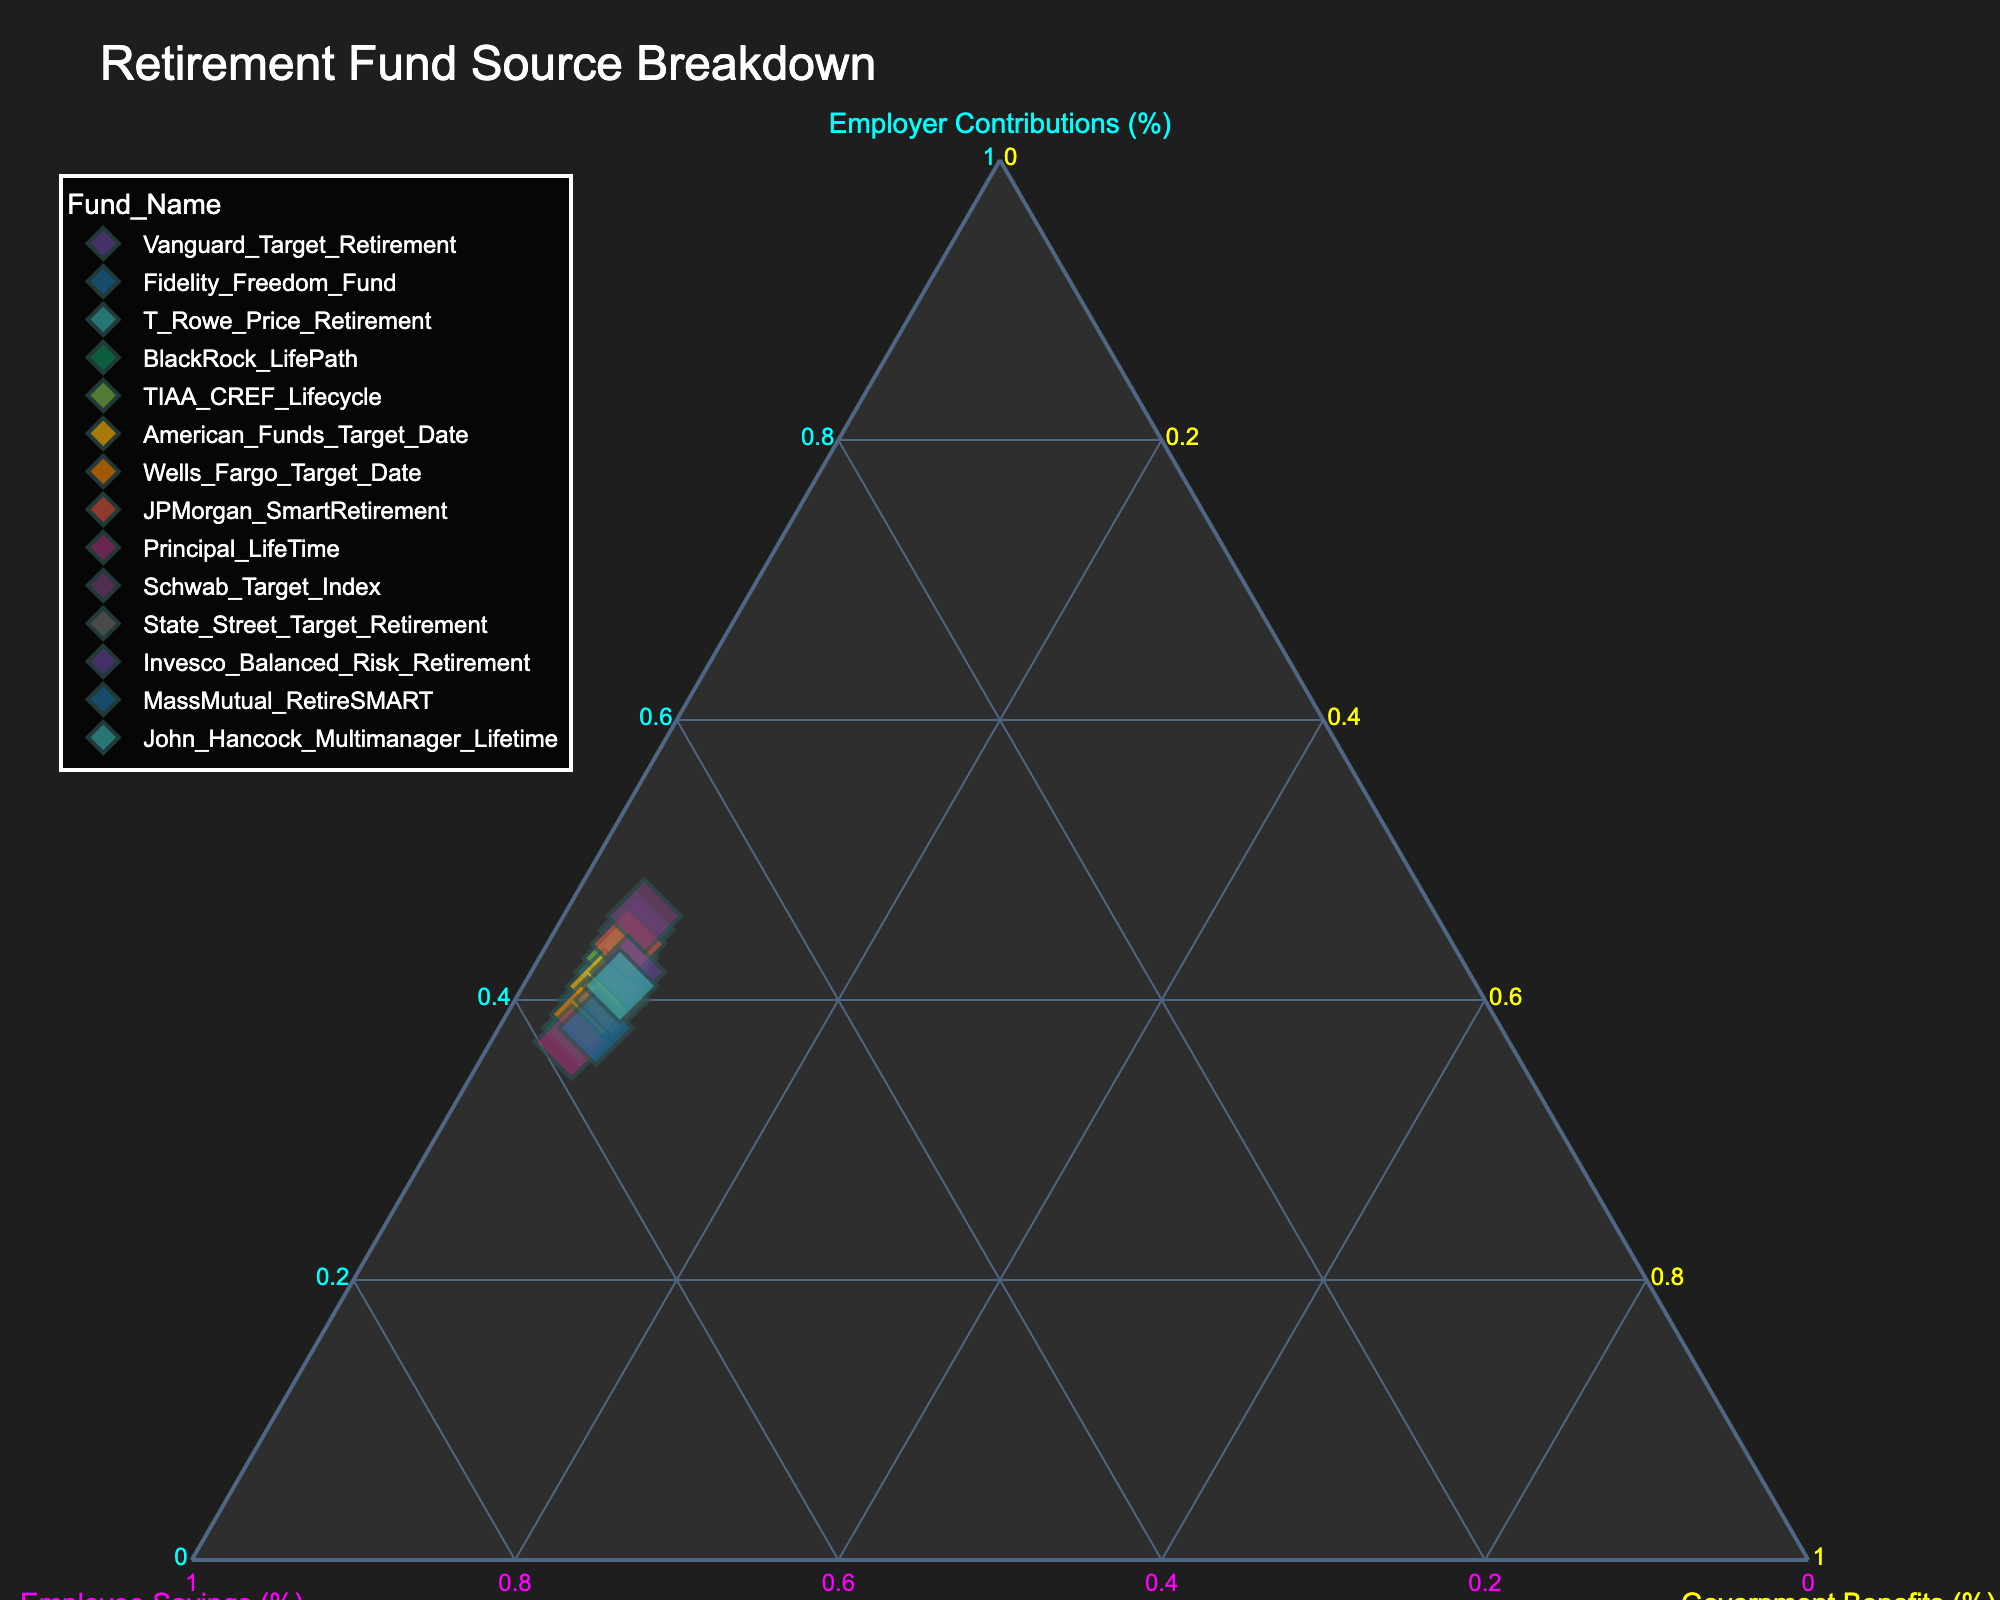How many data points are there on the plot? The plot has one marker per fund, and there are 14 different retirement funds listed.
Answer: 14 What are the three axes in the plot? The plot is a ternary plot, so it has three axes: Employer Contributions (%), Employee Savings (%), and Government Benefits (%).
Answer: Employer Contributions (%), Employee Savings (%), and Government Benefits (%) Which fund has the highest Employee Savings percentage? By looking at the data points on the Employee Savings axis, Principal LifeTime has the highest Employee Savings percentage of 58%.
Answer: Principal LifeTime What is the range of Employer Contributions percentages displayed on the plot? By observing the points along the Employer Contributions axis, the lowest is 37% and the highest is 46%.
Answer: 37% to 46% Which funds have exactly 5% Government Benefits? Checking the coordinates of the data points, these funds have 5% Government Benefits: Vanguard Target Retirement, Fidelity Freedom Fund, T. Rowe Price Retirement, BlackRock LifePath, TIAA-CREF Lifecycle, American Funds Target Date, Wells Fargo Target Date, JPMorgan SmartRetirement, Principal LifeTime, Schwab Target Index.
Answer: Vanguard Target Retirement, Fidelity Freedom Fund, T. Rowe Price Retirement, BlackRock LifePath, TIAA-CREF Lifecycle, American Funds Target Date, Wells Fargo Target Date, JPMorgan SmartRetirement, Principal LifeTime, Schwab Target Index How many funds have Employee Savings of 55% or more? Observing the Employee Savings axis, these funds have 55% or more: Fidelity Freedom Fund (55%), T. Rowe Price Retirement (55%), BlackRock LifePath (57%), Wells Fargo Target Date (56%), Principal LifeTime (58%), and MassMutual RetireSMART (56%). There are 6 funds in total.
Answer: 6 What is the average Employer Contributions percentage across all funds? Sum of Employer Contributions percentages (45 + 40 + 42 + 38 + 43 + 41 + 39 + 44 + 37 + 46 + 40 + 42 + 38 + 41) = 576. The average is 576 / 14 = 41.14%.
Answer: 41.14% Which fund has the most balanced breakdown of Employer Contributions, Employee Savings, and Government Benefits? A balanced breakdown indicates percentages close to equal across the three axes. By closely observing the points on the plot, JPMorgan SmartRetirement has 44% Employer Contributions, 51% Employee Savings, and 5% Government Benefits which is relatively balanced in comparison to others.
Answer: JPMorgan SmartRetirement Compare Employer Contributions percentages of Vanguard Target Retirement and Schwab Target Index Vanguard has 45% Employer Contributions, and Schwab has 46%, making Schwab's Employer Contributions slightly higher than Vanguard's.
Answer: Schwab Target Index What is the total percentage of Government Benefits for all funds combined? Summing the Government Benefits percentages for all funds (5 + 5 + 5 + 5 + 5 + 5 + 5 + 5 + 5 + 5 + 6 + 6 + 6 + 6) = 74%.
Answer: 74% 